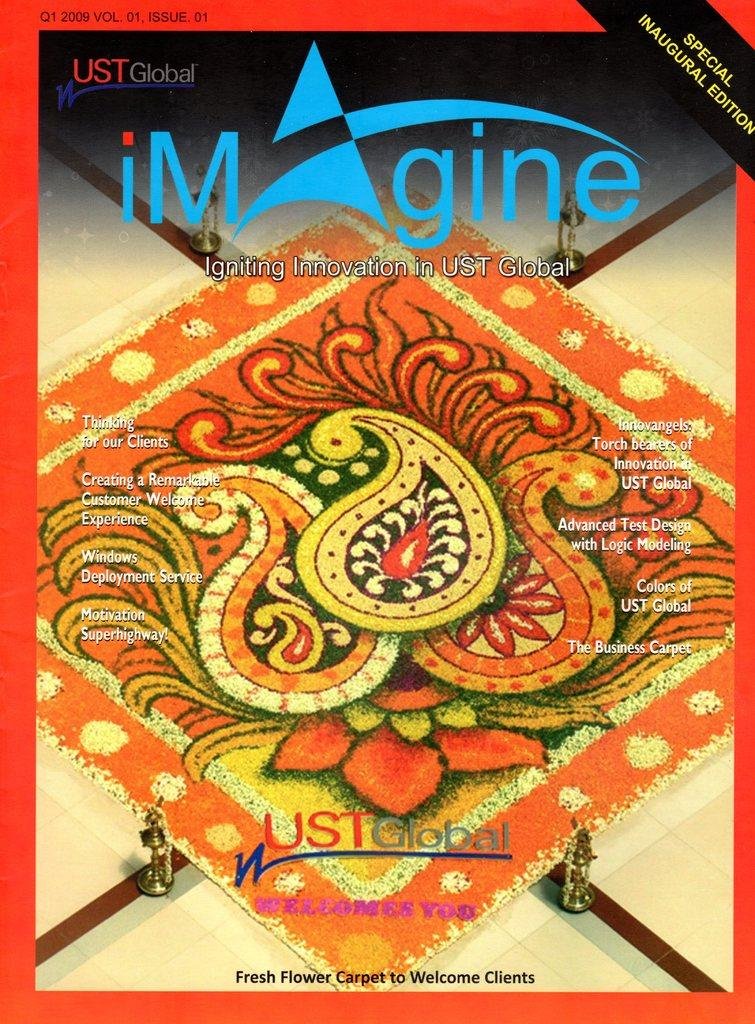<image>
Present a compact description of the photo's key features. A copy of a Special Inaugural Edition of the UST Global magagine. 